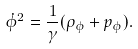<formula> <loc_0><loc_0><loc_500><loc_500>\dot { \phi } ^ { 2 } = \frac { 1 } { \gamma } ( \rho _ { \phi } + p _ { \phi } ) .</formula> 